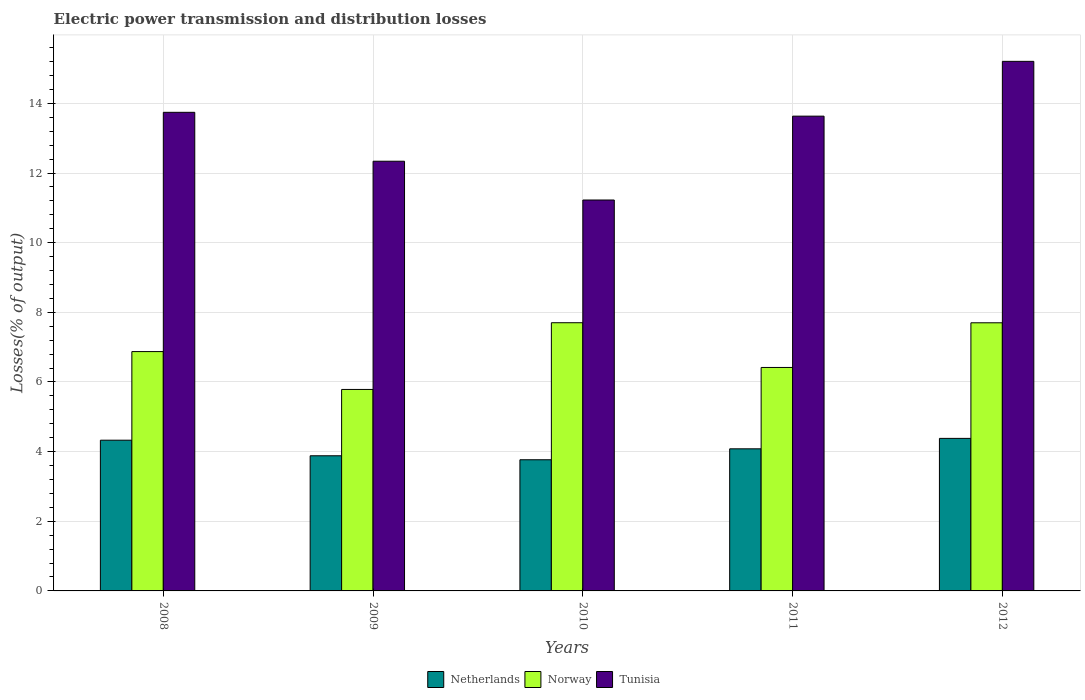How many groups of bars are there?
Make the answer very short. 5. Are the number of bars per tick equal to the number of legend labels?
Your answer should be compact. Yes. Are the number of bars on each tick of the X-axis equal?
Ensure brevity in your answer.  Yes. How many bars are there on the 1st tick from the right?
Ensure brevity in your answer.  3. What is the label of the 2nd group of bars from the left?
Your answer should be compact. 2009. What is the electric power transmission and distribution losses in Tunisia in 2009?
Provide a short and direct response. 12.34. Across all years, what is the maximum electric power transmission and distribution losses in Tunisia?
Your answer should be compact. 15.21. Across all years, what is the minimum electric power transmission and distribution losses in Norway?
Keep it short and to the point. 5.79. In which year was the electric power transmission and distribution losses in Norway maximum?
Give a very brief answer. 2010. In which year was the electric power transmission and distribution losses in Norway minimum?
Provide a succinct answer. 2009. What is the total electric power transmission and distribution losses in Tunisia in the graph?
Ensure brevity in your answer.  66.15. What is the difference between the electric power transmission and distribution losses in Tunisia in 2010 and that in 2011?
Make the answer very short. -2.41. What is the difference between the electric power transmission and distribution losses in Tunisia in 2011 and the electric power transmission and distribution losses in Netherlands in 2008?
Your answer should be very brief. 9.31. What is the average electric power transmission and distribution losses in Netherlands per year?
Provide a succinct answer. 4.09. In the year 2009, what is the difference between the electric power transmission and distribution losses in Netherlands and electric power transmission and distribution losses in Norway?
Give a very brief answer. -1.9. What is the ratio of the electric power transmission and distribution losses in Tunisia in 2009 to that in 2011?
Offer a very short reply. 0.91. Is the electric power transmission and distribution losses in Netherlands in 2008 less than that in 2011?
Your answer should be very brief. No. What is the difference between the highest and the second highest electric power transmission and distribution losses in Tunisia?
Make the answer very short. 1.46. What is the difference between the highest and the lowest electric power transmission and distribution losses in Netherlands?
Make the answer very short. 0.61. Is the sum of the electric power transmission and distribution losses in Tunisia in 2009 and 2010 greater than the maximum electric power transmission and distribution losses in Norway across all years?
Your response must be concise. Yes. What does the 3rd bar from the left in 2012 represents?
Your response must be concise. Tunisia. What does the 1st bar from the right in 2011 represents?
Provide a short and direct response. Tunisia. Is it the case that in every year, the sum of the electric power transmission and distribution losses in Netherlands and electric power transmission and distribution losses in Tunisia is greater than the electric power transmission and distribution losses in Norway?
Offer a terse response. Yes. Are all the bars in the graph horizontal?
Your answer should be compact. No. How many years are there in the graph?
Make the answer very short. 5. Are the values on the major ticks of Y-axis written in scientific E-notation?
Your answer should be compact. No. How many legend labels are there?
Offer a very short reply. 3. How are the legend labels stacked?
Your response must be concise. Horizontal. What is the title of the graph?
Ensure brevity in your answer.  Electric power transmission and distribution losses. What is the label or title of the X-axis?
Make the answer very short. Years. What is the label or title of the Y-axis?
Your answer should be compact. Losses(% of output). What is the Losses(% of output) in Netherlands in 2008?
Your response must be concise. 4.33. What is the Losses(% of output) in Norway in 2008?
Your answer should be very brief. 6.87. What is the Losses(% of output) in Tunisia in 2008?
Provide a short and direct response. 13.74. What is the Losses(% of output) in Netherlands in 2009?
Your answer should be very brief. 3.88. What is the Losses(% of output) of Norway in 2009?
Your response must be concise. 5.79. What is the Losses(% of output) in Tunisia in 2009?
Keep it short and to the point. 12.34. What is the Losses(% of output) in Netherlands in 2010?
Your response must be concise. 3.77. What is the Losses(% of output) of Norway in 2010?
Provide a succinct answer. 7.7. What is the Losses(% of output) in Tunisia in 2010?
Provide a short and direct response. 11.23. What is the Losses(% of output) in Netherlands in 2011?
Make the answer very short. 4.08. What is the Losses(% of output) in Norway in 2011?
Ensure brevity in your answer.  6.42. What is the Losses(% of output) in Tunisia in 2011?
Your response must be concise. 13.63. What is the Losses(% of output) of Netherlands in 2012?
Offer a very short reply. 4.38. What is the Losses(% of output) of Norway in 2012?
Your response must be concise. 7.7. What is the Losses(% of output) of Tunisia in 2012?
Your answer should be compact. 15.21. Across all years, what is the maximum Losses(% of output) in Netherlands?
Your response must be concise. 4.38. Across all years, what is the maximum Losses(% of output) in Norway?
Offer a very short reply. 7.7. Across all years, what is the maximum Losses(% of output) of Tunisia?
Offer a terse response. 15.21. Across all years, what is the minimum Losses(% of output) of Netherlands?
Provide a short and direct response. 3.77. Across all years, what is the minimum Losses(% of output) of Norway?
Ensure brevity in your answer.  5.79. Across all years, what is the minimum Losses(% of output) in Tunisia?
Give a very brief answer. 11.23. What is the total Losses(% of output) in Netherlands in the graph?
Provide a succinct answer. 20.44. What is the total Losses(% of output) in Norway in the graph?
Keep it short and to the point. 34.48. What is the total Losses(% of output) in Tunisia in the graph?
Provide a succinct answer. 66.15. What is the difference between the Losses(% of output) of Netherlands in 2008 and that in 2009?
Give a very brief answer. 0.45. What is the difference between the Losses(% of output) of Norway in 2008 and that in 2009?
Provide a succinct answer. 1.09. What is the difference between the Losses(% of output) of Tunisia in 2008 and that in 2009?
Give a very brief answer. 1.4. What is the difference between the Losses(% of output) in Netherlands in 2008 and that in 2010?
Make the answer very short. 0.56. What is the difference between the Losses(% of output) of Norway in 2008 and that in 2010?
Offer a terse response. -0.83. What is the difference between the Losses(% of output) in Tunisia in 2008 and that in 2010?
Your answer should be very brief. 2.52. What is the difference between the Losses(% of output) in Netherlands in 2008 and that in 2011?
Keep it short and to the point. 0.25. What is the difference between the Losses(% of output) of Norway in 2008 and that in 2011?
Your answer should be compact. 0.46. What is the difference between the Losses(% of output) in Tunisia in 2008 and that in 2011?
Your response must be concise. 0.11. What is the difference between the Losses(% of output) in Netherlands in 2008 and that in 2012?
Provide a succinct answer. -0.05. What is the difference between the Losses(% of output) of Norway in 2008 and that in 2012?
Your answer should be compact. -0.83. What is the difference between the Losses(% of output) of Tunisia in 2008 and that in 2012?
Provide a succinct answer. -1.46. What is the difference between the Losses(% of output) of Netherlands in 2009 and that in 2010?
Your response must be concise. 0.11. What is the difference between the Losses(% of output) of Norway in 2009 and that in 2010?
Your answer should be compact. -1.92. What is the difference between the Losses(% of output) in Tunisia in 2009 and that in 2010?
Give a very brief answer. 1.11. What is the difference between the Losses(% of output) in Netherlands in 2009 and that in 2011?
Give a very brief answer. -0.2. What is the difference between the Losses(% of output) in Norway in 2009 and that in 2011?
Your answer should be compact. -0.63. What is the difference between the Losses(% of output) in Tunisia in 2009 and that in 2011?
Offer a terse response. -1.29. What is the difference between the Losses(% of output) in Netherlands in 2009 and that in 2012?
Ensure brevity in your answer.  -0.5. What is the difference between the Losses(% of output) of Norway in 2009 and that in 2012?
Keep it short and to the point. -1.91. What is the difference between the Losses(% of output) of Tunisia in 2009 and that in 2012?
Offer a terse response. -2.87. What is the difference between the Losses(% of output) in Netherlands in 2010 and that in 2011?
Ensure brevity in your answer.  -0.31. What is the difference between the Losses(% of output) in Norway in 2010 and that in 2011?
Your answer should be compact. 1.28. What is the difference between the Losses(% of output) of Tunisia in 2010 and that in 2011?
Offer a very short reply. -2.41. What is the difference between the Losses(% of output) in Netherlands in 2010 and that in 2012?
Your answer should be very brief. -0.61. What is the difference between the Losses(% of output) of Norway in 2010 and that in 2012?
Ensure brevity in your answer.  0. What is the difference between the Losses(% of output) of Tunisia in 2010 and that in 2012?
Give a very brief answer. -3.98. What is the difference between the Losses(% of output) of Netherlands in 2011 and that in 2012?
Provide a succinct answer. -0.3. What is the difference between the Losses(% of output) in Norway in 2011 and that in 2012?
Your answer should be compact. -1.28. What is the difference between the Losses(% of output) in Tunisia in 2011 and that in 2012?
Your answer should be very brief. -1.57. What is the difference between the Losses(% of output) of Netherlands in 2008 and the Losses(% of output) of Norway in 2009?
Offer a terse response. -1.46. What is the difference between the Losses(% of output) in Netherlands in 2008 and the Losses(% of output) in Tunisia in 2009?
Offer a terse response. -8.01. What is the difference between the Losses(% of output) in Norway in 2008 and the Losses(% of output) in Tunisia in 2009?
Your answer should be very brief. -5.47. What is the difference between the Losses(% of output) of Netherlands in 2008 and the Losses(% of output) of Norway in 2010?
Make the answer very short. -3.37. What is the difference between the Losses(% of output) in Netherlands in 2008 and the Losses(% of output) in Tunisia in 2010?
Provide a succinct answer. -6.9. What is the difference between the Losses(% of output) of Norway in 2008 and the Losses(% of output) of Tunisia in 2010?
Your response must be concise. -4.35. What is the difference between the Losses(% of output) in Netherlands in 2008 and the Losses(% of output) in Norway in 2011?
Your response must be concise. -2.09. What is the difference between the Losses(% of output) of Netherlands in 2008 and the Losses(% of output) of Tunisia in 2011?
Your response must be concise. -9.31. What is the difference between the Losses(% of output) of Norway in 2008 and the Losses(% of output) of Tunisia in 2011?
Keep it short and to the point. -6.76. What is the difference between the Losses(% of output) of Netherlands in 2008 and the Losses(% of output) of Norway in 2012?
Offer a terse response. -3.37. What is the difference between the Losses(% of output) of Netherlands in 2008 and the Losses(% of output) of Tunisia in 2012?
Offer a terse response. -10.88. What is the difference between the Losses(% of output) in Norway in 2008 and the Losses(% of output) in Tunisia in 2012?
Your response must be concise. -8.33. What is the difference between the Losses(% of output) in Netherlands in 2009 and the Losses(% of output) in Norway in 2010?
Your response must be concise. -3.82. What is the difference between the Losses(% of output) in Netherlands in 2009 and the Losses(% of output) in Tunisia in 2010?
Provide a short and direct response. -7.34. What is the difference between the Losses(% of output) in Norway in 2009 and the Losses(% of output) in Tunisia in 2010?
Provide a succinct answer. -5.44. What is the difference between the Losses(% of output) of Netherlands in 2009 and the Losses(% of output) of Norway in 2011?
Your response must be concise. -2.54. What is the difference between the Losses(% of output) in Netherlands in 2009 and the Losses(% of output) in Tunisia in 2011?
Offer a terse response. -9.75. What is the difference between the Losses(% of output) in Norway in 2009 and the Losses(% of output) in Tunisia in 2011?
Your response must be concise. -7.85. What is the difference between the Losses(% of output) in Netherlands in 2009 and the Losses(% of output) in Norway in 2012?
Ensure brevity in your answer.  -3.82. What is the difference between the Losses(% of output) of Netherlands in 2009 and the Losses(% of output) of Tunisia in 2012?
Make the answer very short. -11.33. What is the difference between the Losses(% of output) of Norway in 2009 and the Losses(% of output) of Tunisia in 2012?
Offer a very short reply. -9.42. What is the difference between the Losses(% of output) in Netherlands in 2010 and the Losses(% of output) in Norway in 2011?
Ensure brevity in your answer.  -2.65. What is the difference between the Losses(% of output) of Netherlands in 2010 and the Losses(% of output) of Tunisia in 2011?
Your answer should be very brief. -9.87. What is the difference between the Losses(% of output) of Norway in 2010 and the Losses(% of output) of Tunisia in 2011?
Keep it short and to the point. -5.93. What is the difference between the Losses(% of output) in Netherlands in 2010 and the Losses(% of output) in Norway in 2012?
Provide a short and direct response. -3.93. What is the difference between the Losses(% of output) of Netherlands in 2010 and the Losses(% of output) of Tunisia in 2012?
Give a very brief answer. -11.44. What is the difference between the Losses(% of output) in Norway in 2010 and the Losses(% of output) in Tunisia in 2012?
Provide a succinct answer. -7.51. What is the difference between the Losses(% of output) in Netherlands in 2011 and the Losses(% of output) in Norway in 2012?
Offer a very short reply. -3.62. What is the difference between the Losses(% of output) of Netherlands in 2011 and the Losses(% of output) of Tunisia in 2012?
Your answer should be very brief. -11.13. What is the difference between the Losses(% of output) in Norway in 2011 and the Losses(% of output) in Tunisia in 2012?
Your response must be concise. -8.79. What is the average Losses(% of output) of Netherlands per year?
Give a very brief answer. 4.09. What is the average Losses(% of output) in Norway per year?
Your answer should be very brief. 6.9. What is the average Losses(% of output) in Tunisia per year?
Offer a terse response. 13.23. In the year 2008, what is the difference between the Losses(% of output) in Netherlands and Losses(% of output) in Norway?
Make the answer very short. -2.54. In the year 2008, what is the difference between the Losses(% of output) of Netherlands and Losses(% of output) of Tunisia?
Your answer should be compact. -9.42. In the year 2008, what is the difference between the Losses(% of output) in Norway and Losses(% of output) in Tunisia?
Provide a succinct answer. -6.87. In the year 2009, what is the difference between the Losses(% of output) of Netherlands and Losses(% of output) of Norway?
Provide a short and direct response. -1.9. In the year 2009, what is the difference between the Losses(% of output) in Netherlands and Losses(% of output) in Tunisia?
Your answer should be compact. -8.46. In the year 2009, what is the difference between the Losses(% of output) of Norway and Losses(% of output) of Tunisia?
Provide a short and direct response. -6.55. In the year 2010, what is the difference between the Losses(% of output) of Netherlands and Losses(% of output) of Norway?
Your response must be concise. -3.93. In the year 2010, what is the difference between the Losses(% of output) in Netherlands and Losses(% of output) in Tunisia?
Your answer should be very brief. -7.46. In the year 2010, what is the difference between the Losses(% of output) in Norway and Losses(% of output) in Tunisia?
Give a very brief answer. -3.52. In the year 2011, what is the difference between the Losses(% of output) of Netherlands and Losses(% of output) of Norway?
Offer a very short reply. -2.34. In the year 2011, what is the difference between the Losses(% of output) in Netherlands and Losses(% of output) in Tunisia?
Your answer should be compact. -9.55. In the year 2011, what is the difference between the Losses(% of output) of Norway and Losses(% of output) of Tunisia?
Provide a short and direct response. -7.22. In the year 2012, what is the difference between the Losses(% of output) in Netherlands and Losses(% of output) in Norway?
Offer a very short reply. -3.32. In the year 2012, what is the difference between the Losses(% of output) in Netherlands and Losses(% of output) in Tunisia?
Your answer should be very brief. -10.83. In the year 2012, what is the difference between the Losses(% of output) in Norway and Losses(% of output) in Tunisia?
Offer a very short reply. -7.51. What is the ratio of the Losses(% of output) in Netherlands in 2008 to that in 2009?
Keep it short and to the point. 1.12. What is the ratio of the Losses(% of output) in Norway in 2008 to that in 2009?
Offer a very short reply. 1.19. What is the ratio of the Losses(% of output) in Tunisia in 2008 to that in 2009?
Provide a succinct answer. 1.11. What is the ratio of the Losses(% of output) of Netherlands in 2008 to that in 2010?
Offer a very short reply. 1.15. What is the ratio of the Losses(% of output) in Norway in 2008 to that in 2010?
Keep it short and to the point. 0.89. What is the ratio of the Losses(% of output) of Tunisia in 2008 to that in 2010?
Offer a very short reply. 1.22. What is the ratio of the Losses(% of output) of Netherlands in 2008 to that in 2011?
Provide a succinct answer. 1.06. What is the ratio of the Losses(% of output) in Norway in 2008 to that in 2011?
Provide a succinct answer. 1.07. What is the ratio of the Losses(% of output) of Netherlands in 2008 to that in 2012?
Offer a very short reply. 0.99. What is the ratio of the Losses(% of output) in Norway in 2008 to that in 2012?
Offer a terse response. 0.89. What is the ratio of the Losses(% of output) in Tunisia in 2008 to that in 2012?
Offer a very short reply. 0.9. What is the ratio of the Losses(% of output) in Netherlands in 2009 to that in 2010?
Make the answer very short. 1.03. What is the ratio of the Losses(% of output) of Norway in 2009 to that in 2010?
Your answer should be very brief. 0.75. What is the ratio of the Losses(% of output) in Tunisia in 2009 to that in 2010?
Your answer should be very brief. 1.1. What is the ratio of the Losses(% of output) in Netherlands in 2009 to that in 2011?
Your answer should be compact. 0.95. What is the ratio of the Losses(% of output) in Norway in 2009 to that in 2011?
Keep it short and to the point. 0.9. What is the ratio of the Losses(% of output) of Tunisia in 2009 to that in 2011?
Your response must be concise. 0.91. What is the ratio of the Losses(% of output) of Netherlands in 2009 to that in 2012?
Keep it short and to the point. 0.89. What is the ratio of the Losses(% of output) of Norway in 2009 to that in 2012?
Your answer should be very brief. 0.75. What is the ratio of the Losses(% of output) of Tunisia in 2009 to that in 2012?
Your answer should be very brief. 0.81. What is the ratio of the Losses(% of output) of Netherlands in 2010 to that in 2011?
Offer a terse response. 0.92. What is the ratio of the Losses(% of output) in Norway in 2010 to that in 2011?
Provide a succinct answer. 1.2. What is the ratio of the Losses(% of output) of Tunisia in 2010 to that in 2011?
Offer a terse response. 0.82. What is the ratio of the Losses(% of output) of Netherlands in 2010 to that in 2012?
Provide a short and direct response. 0.86. What is the ratio of the Losses(% of output) in Tunisia in 2010 to that in 2012?
Make the answer very short. 0.74. What is the ratio of the Losses(% of output) of Netherlands in 2011 to that in 2012?
Provide a succinct answer. 0.93. What is the ratio of the Losses(% of output) in Norway in 2011 to that in 2012?
Ensure brevity in your answer.  0.83. What is the ratio of the Losses(% of output) in Tunisia in 2011 to that in 2012?
Offer a terse response. 0.9. What is the difference between the highest and the second highest Losses(% of output) of Netherlands?
Make the answer very short. 0.05. What is the difference between the highest and the second highest Losses(% of output) in Norway?
Offer a very short reply. 0. What is the difference between the highest and the second highest Losses(% of output) of Tunisia?
Offer a very short reply. 1.46. What is the difference between the highest and the lowest Losses(% of output) in Netherlands?
Your answer should be compact. 0.61. What is the difference between the highest and the lowest Losses(% of output) in Norway?
Offer a terse response. 1.92. What is the difference between the highest and the lowest Losses(% of output) in Tunisia?
Provide a short and direct response. 3.98. 